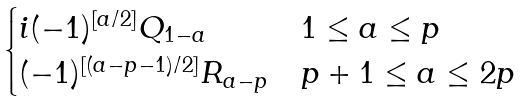Convert formula to latex. <formula><loc_0><loc_0><loc_500><loc_500>\begin{cases} i ( - 1 ) ^ { [ a / 2 ] } Q _ { 1 - a } & 1 \leq a \leq p \\ ( - 1 ) ^ { [ ( a - p - 1 ) / 2 ] } R _ { a - p } & p + 1 \leq a \leq 2 p \end{cases}</formula> 